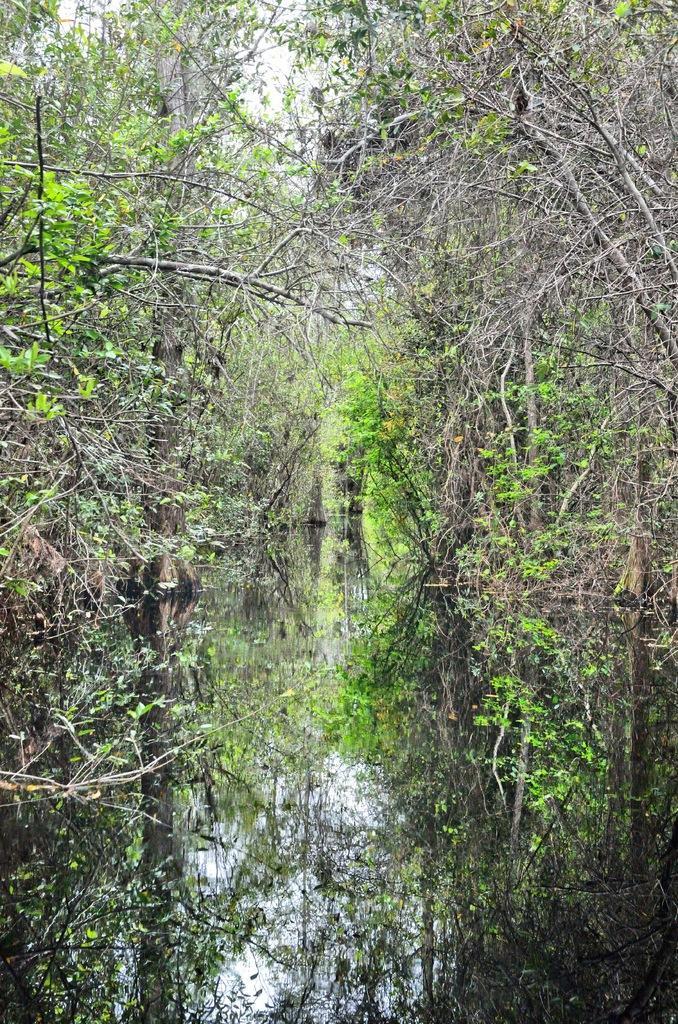Please provide a concise description of this image. In this image we can see many trees and plants. We can see the reflection of trees, plants and the sky on the water surface. We can see the sky in the image. 